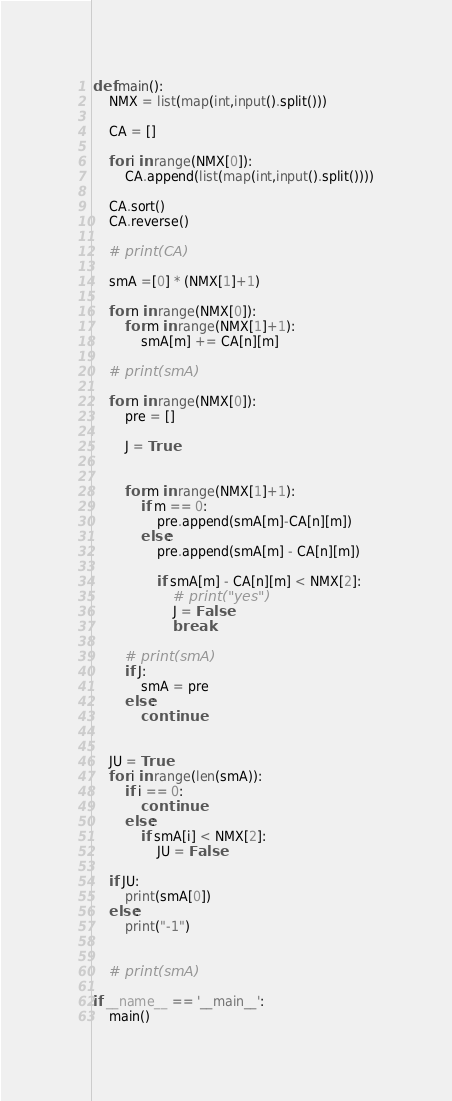<code> <loc_0><loc_0><loc_500><loc_500><_Python_>

def main():
    NMX = list(map(int,input().split()))

    CA = []

    for i in range(NMX[0]):
        CA.append(list(map(int,input().split())))

    CA.sort()
    CA.reverse()

    # print(CA)

    smA =[0] * (NMX[1]+1)

    for n in range(NMX[0]):
        for m in range(NMX[1]+1):
            smA[m] += CA[n][m]

    # print(smA)

    for n in range(NMX[0]):
        pre = []

        J = True


        for m in range(NMX[1]+1):
            if m == 0:
                pre.append(smA[m]-CA[n][m])
            else:
                pre.append(smA[m] - CA[n][m])

                if smA[m] - CA[n][m] < NMX[2]:
                    # print("yes")
                    J = False
                    break

        # print(smA)
        if J:
            smA = pre
        else:
            continue


    JU = True
    for i in range(len(smA)):
        if i == 0:
            continue
        else:
            if smA[i] < NMX[2]:
                JU = False

    if JU:
        print(smA[0])
    else:
        print("-1")


    # print(smA)

if __name__ == '__main__':
    main()

</code> 